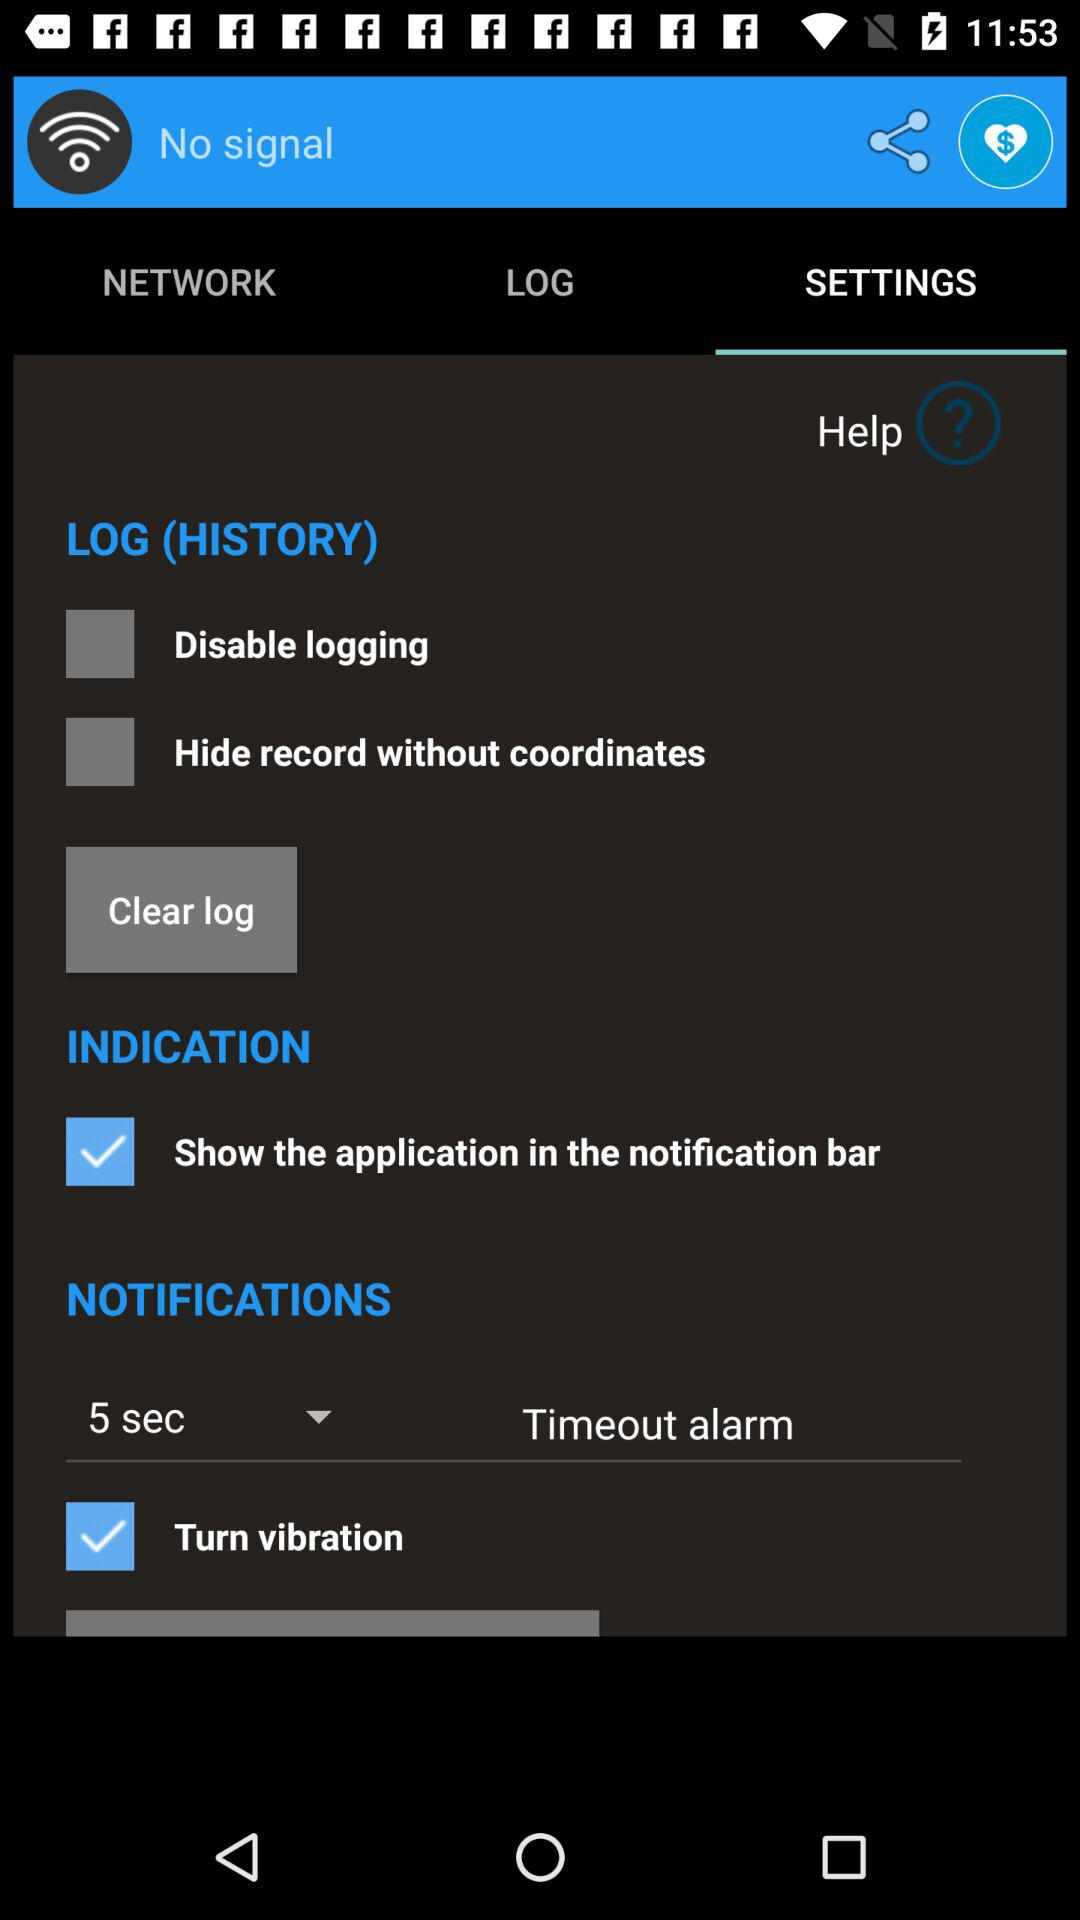Which tab is selected? The selected tab is "SETTINGS". 